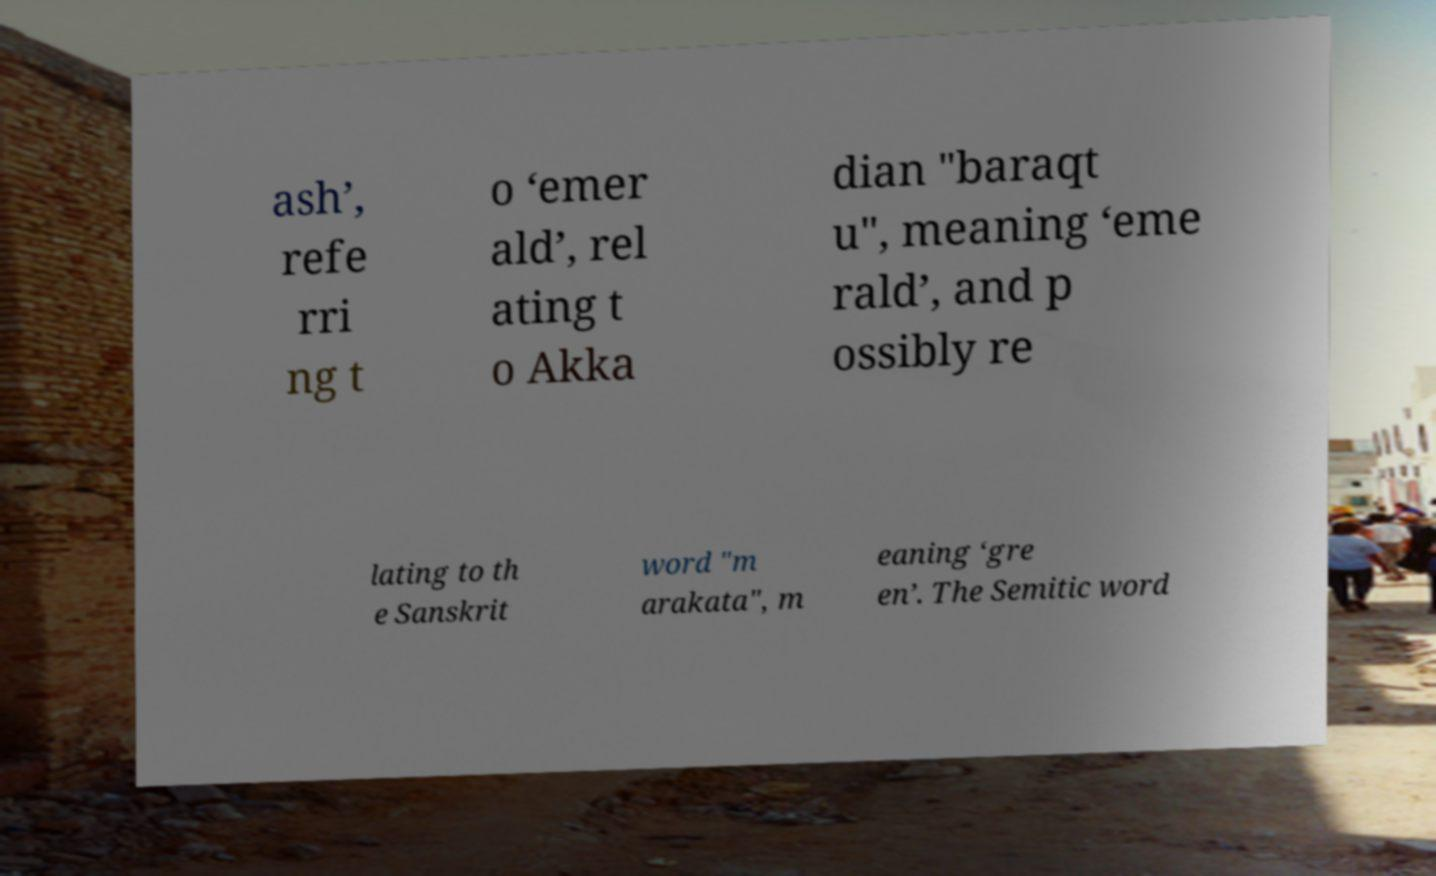Please identify and transcribe the text found in this image. ash’, refe rri ng t o ‘emer ald’, rel ating t o Akka dian "baraqt u", meaning ‘eme rald’, and p ossibly re lating to th e Sanskrit word "m arakata", m eaning ‘gre en’. The Semitic word 